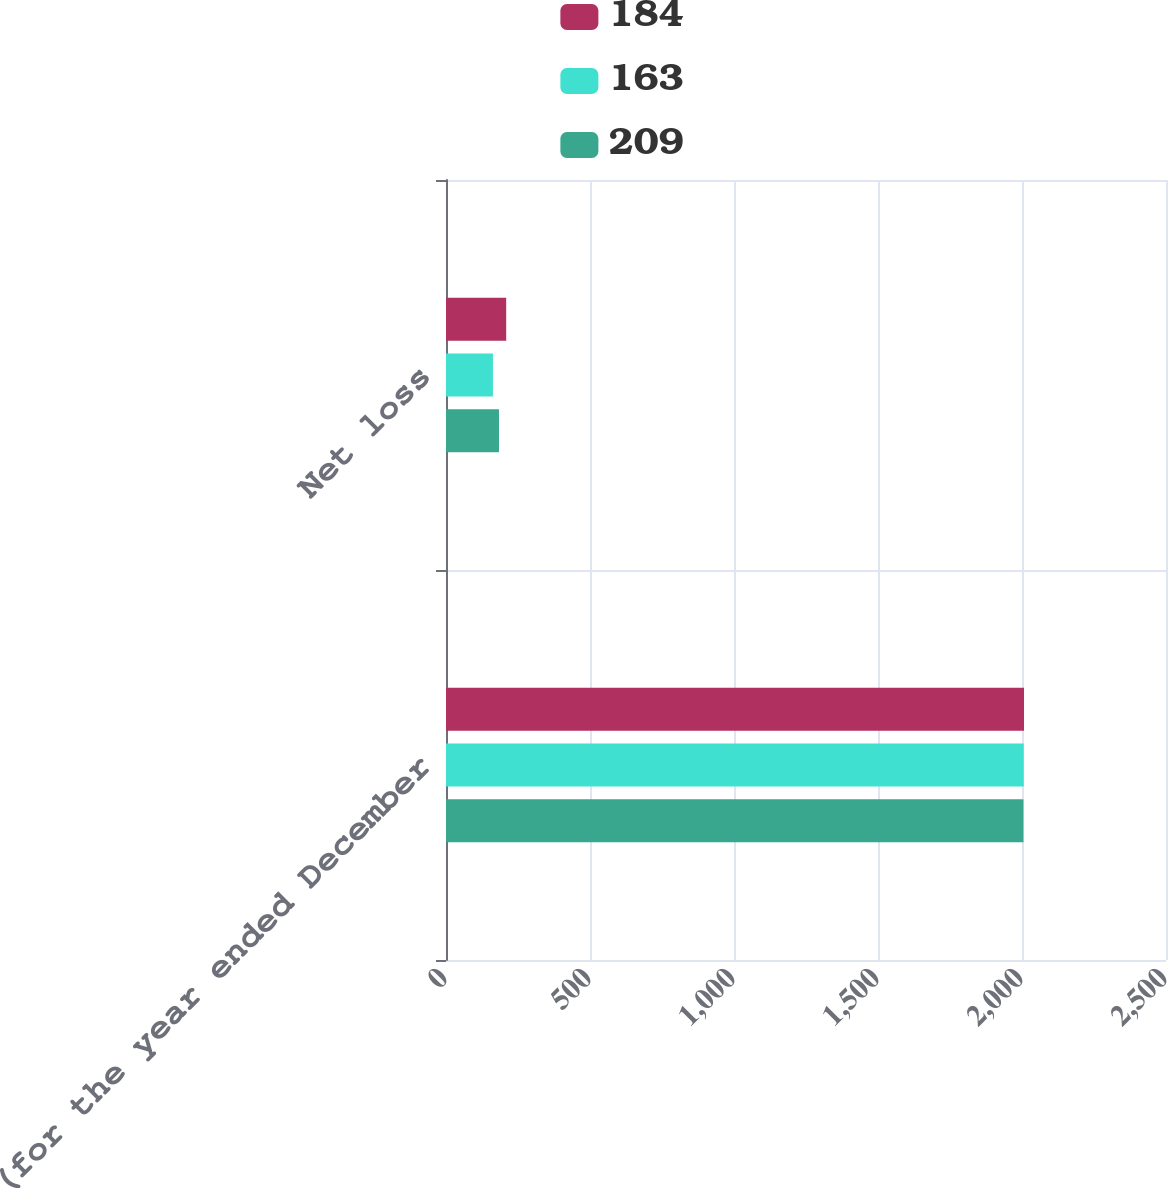<chart> <loc_0><loc_0><loc_500><loc_500><stacked_bar_chart><ecel><fcel>(for the year ended December<fcel>Net loss<nl><fcel>184<fcel>2007<fcel>209<nl><fcel>163<fcel>2006<fcel>163<nl><fcel>209<fcel>2005<fcel>184<nl></chart> 